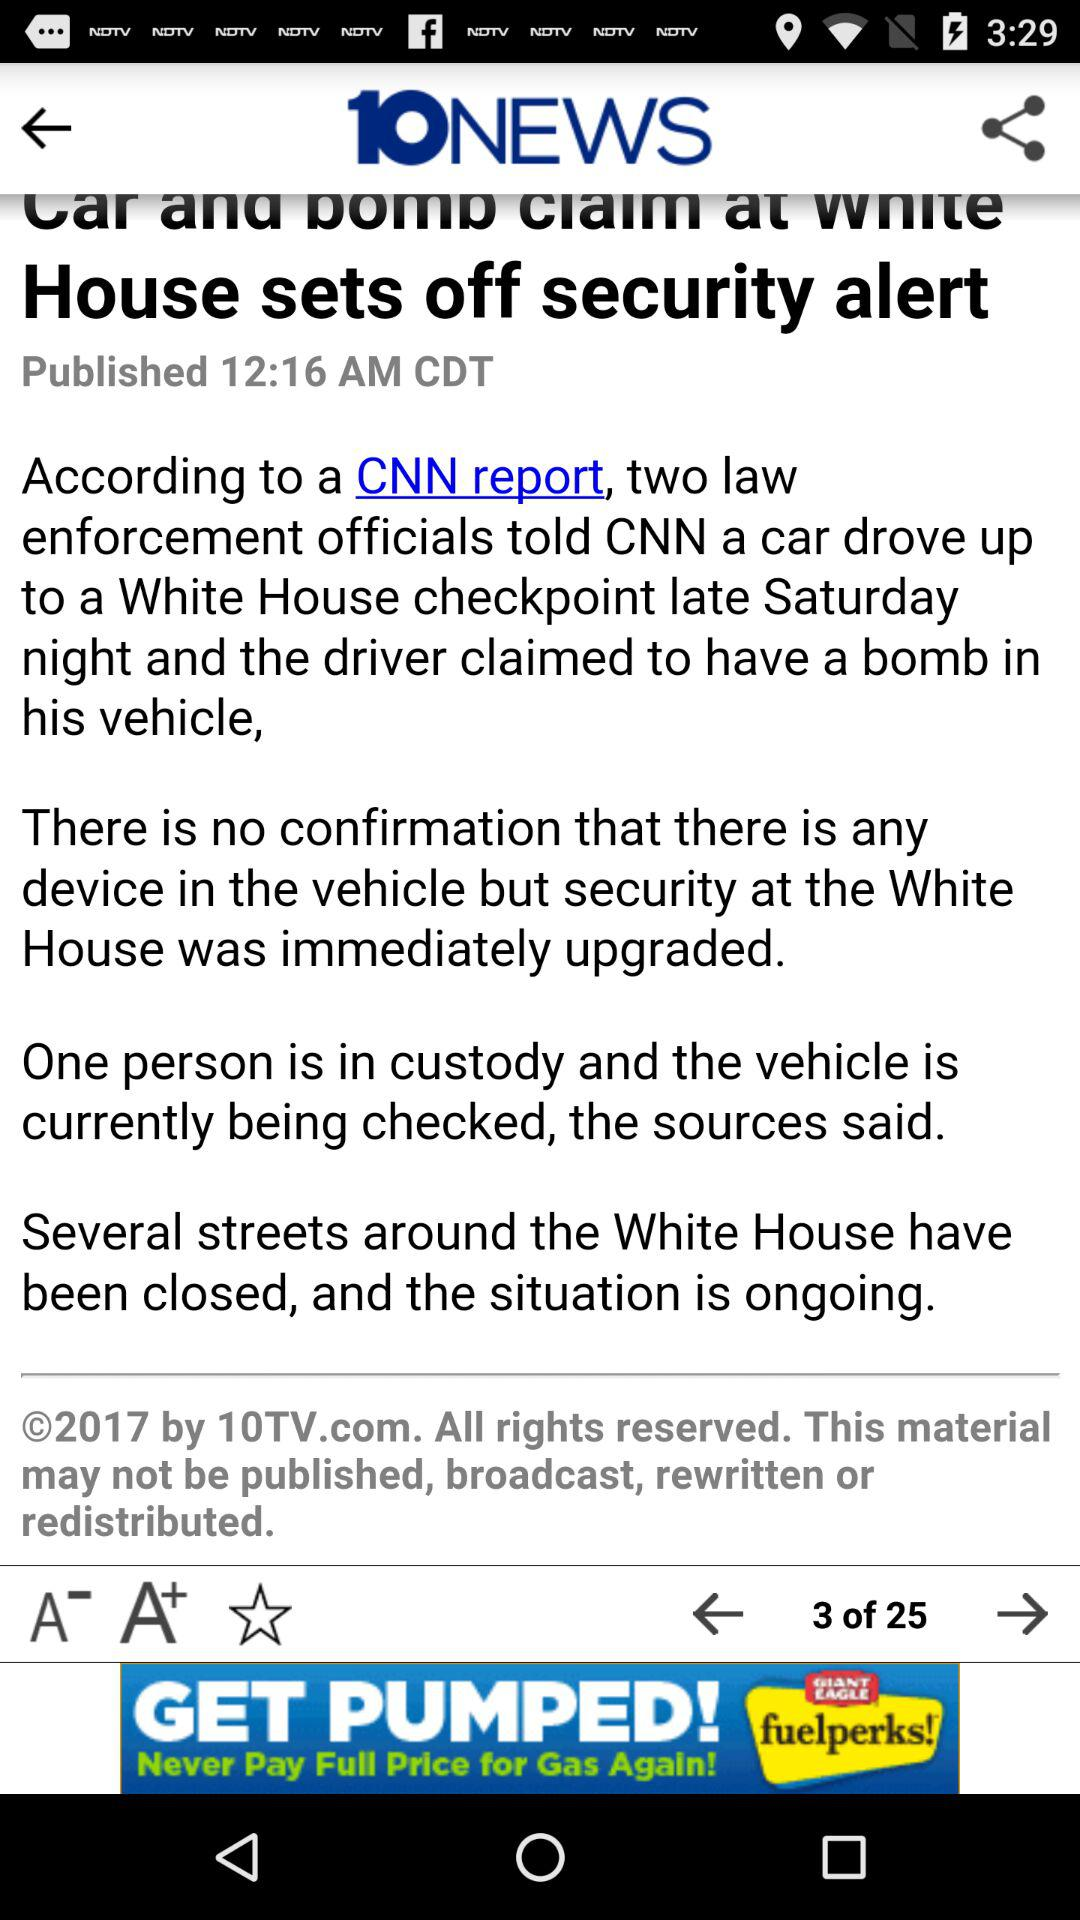What is the year of copyright for the news channel? The year of copyright is 2017. 